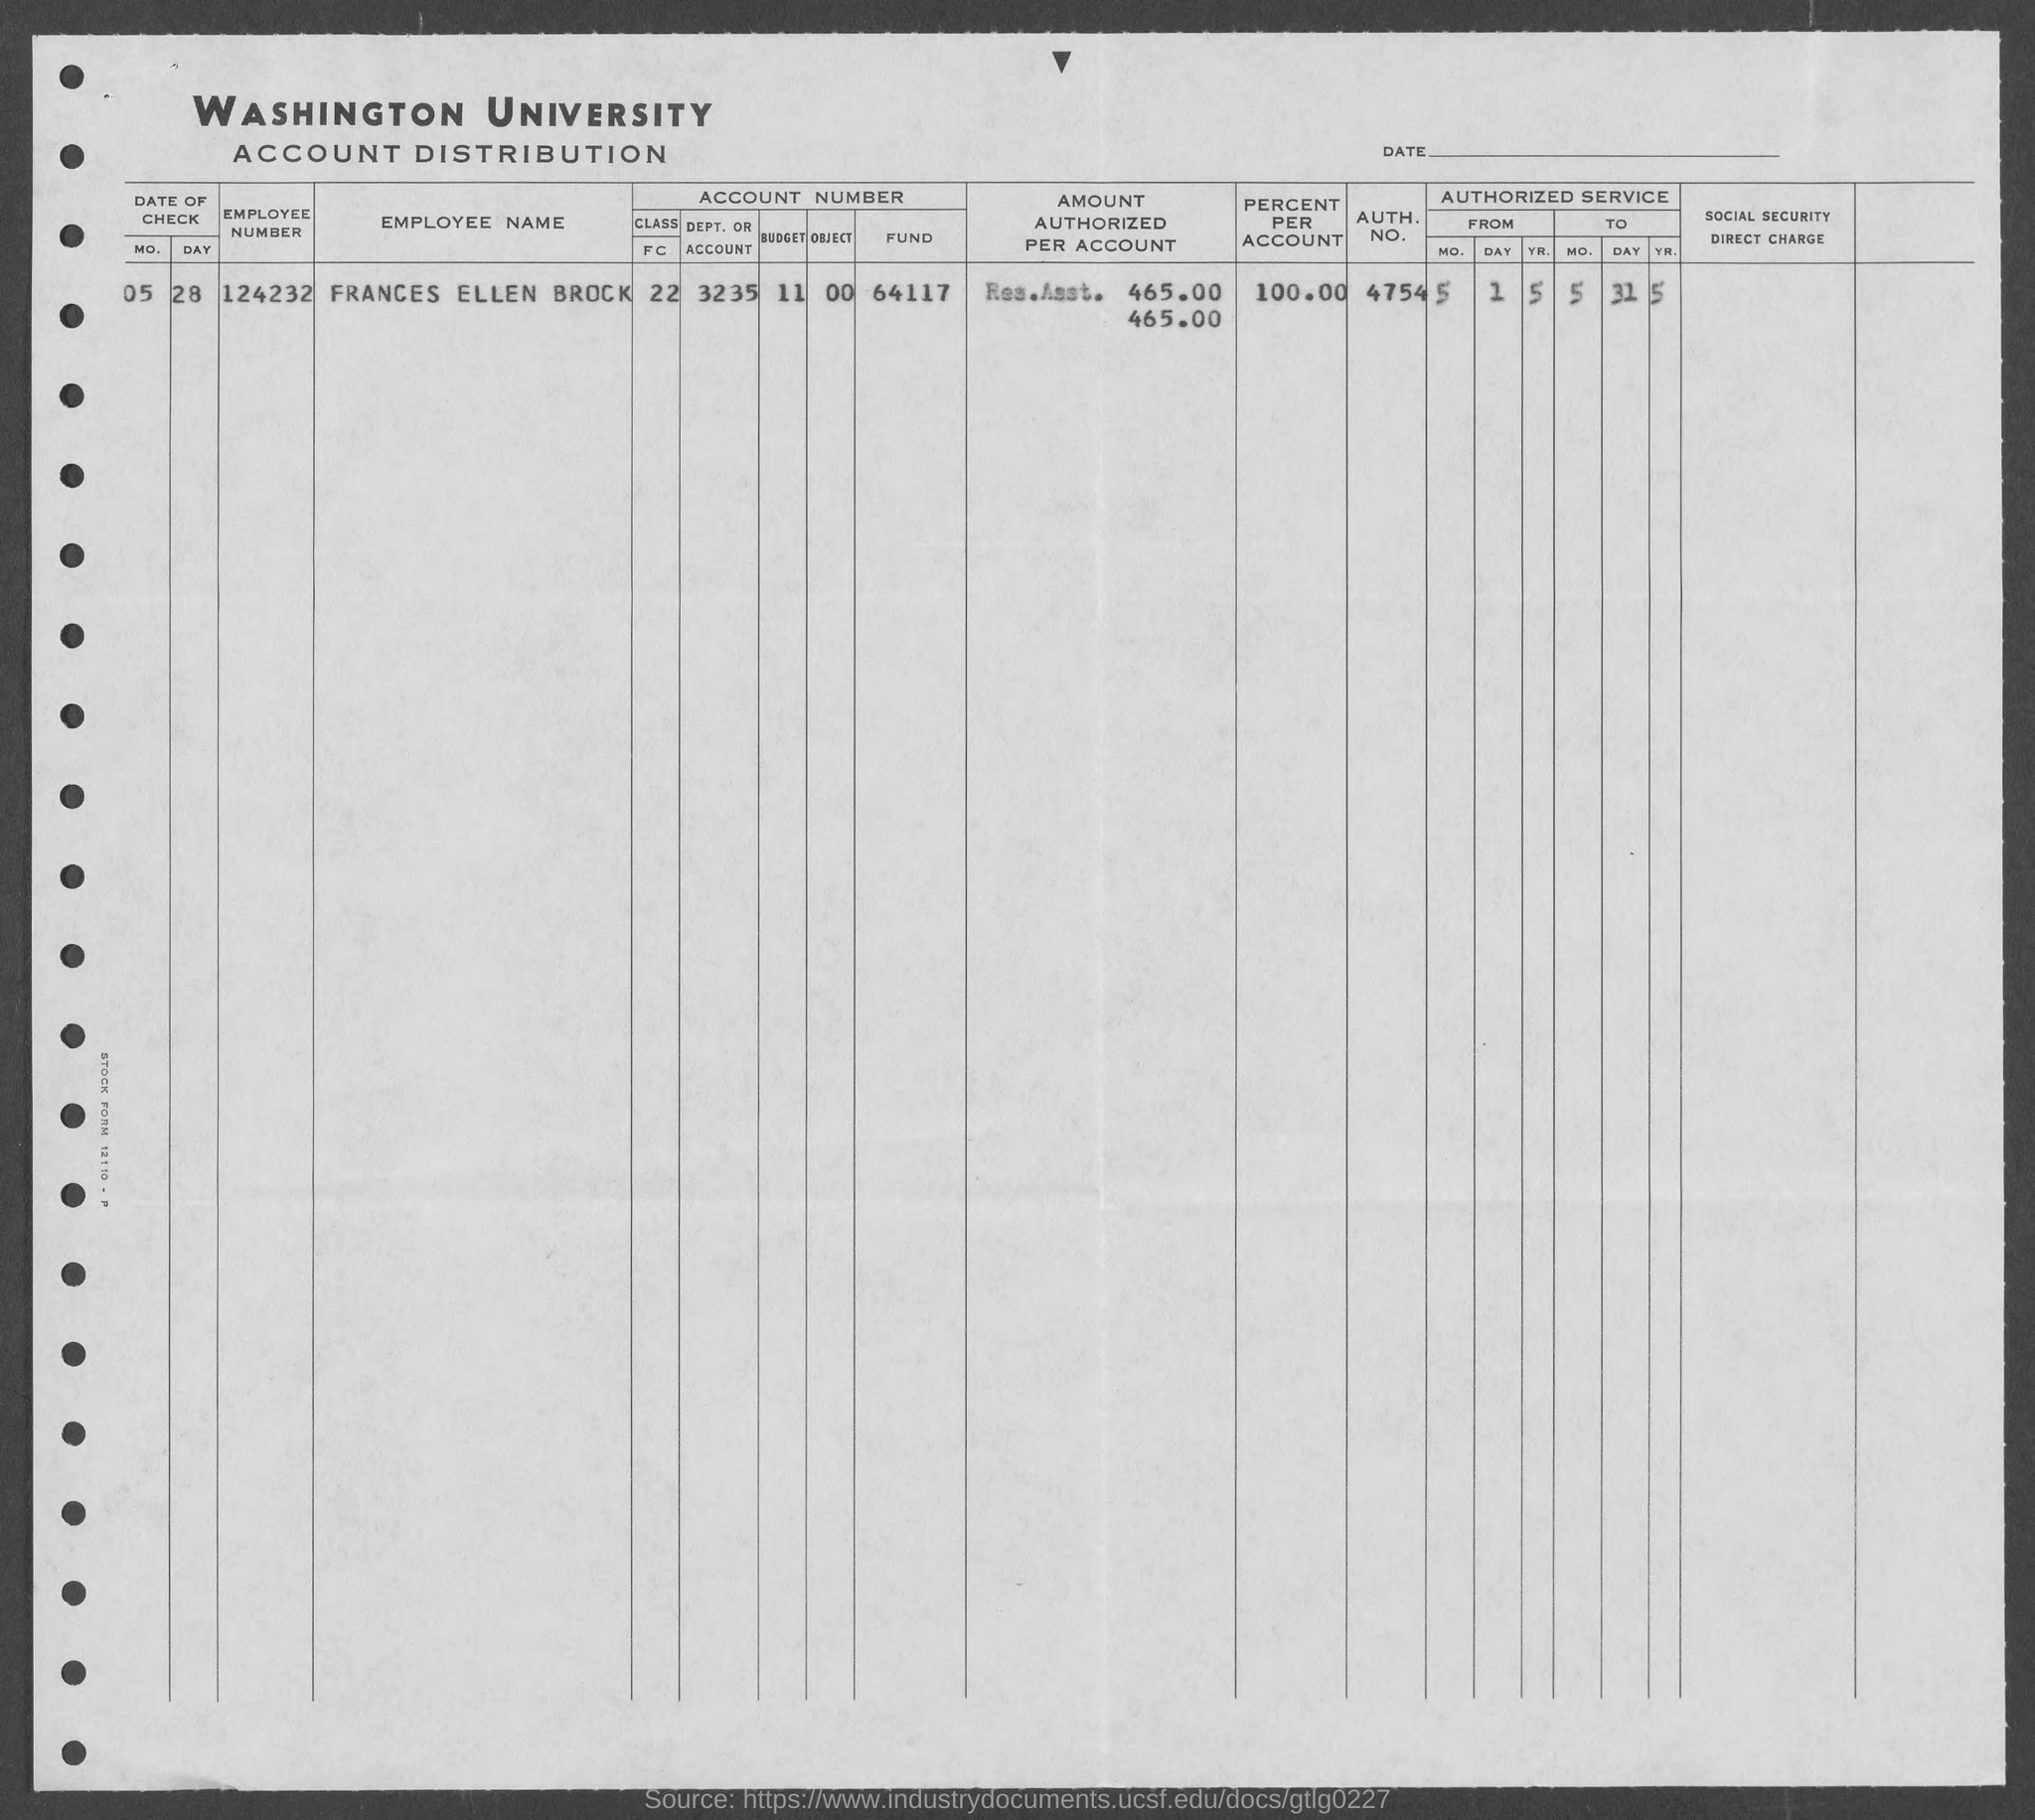Highlight a few significant elements in this photo. The AUTH. NO. is 4754. The percent per account is 100.00. The employee number is 124232... The letterhead mentions WASHINGTON UNIVERSITY. 